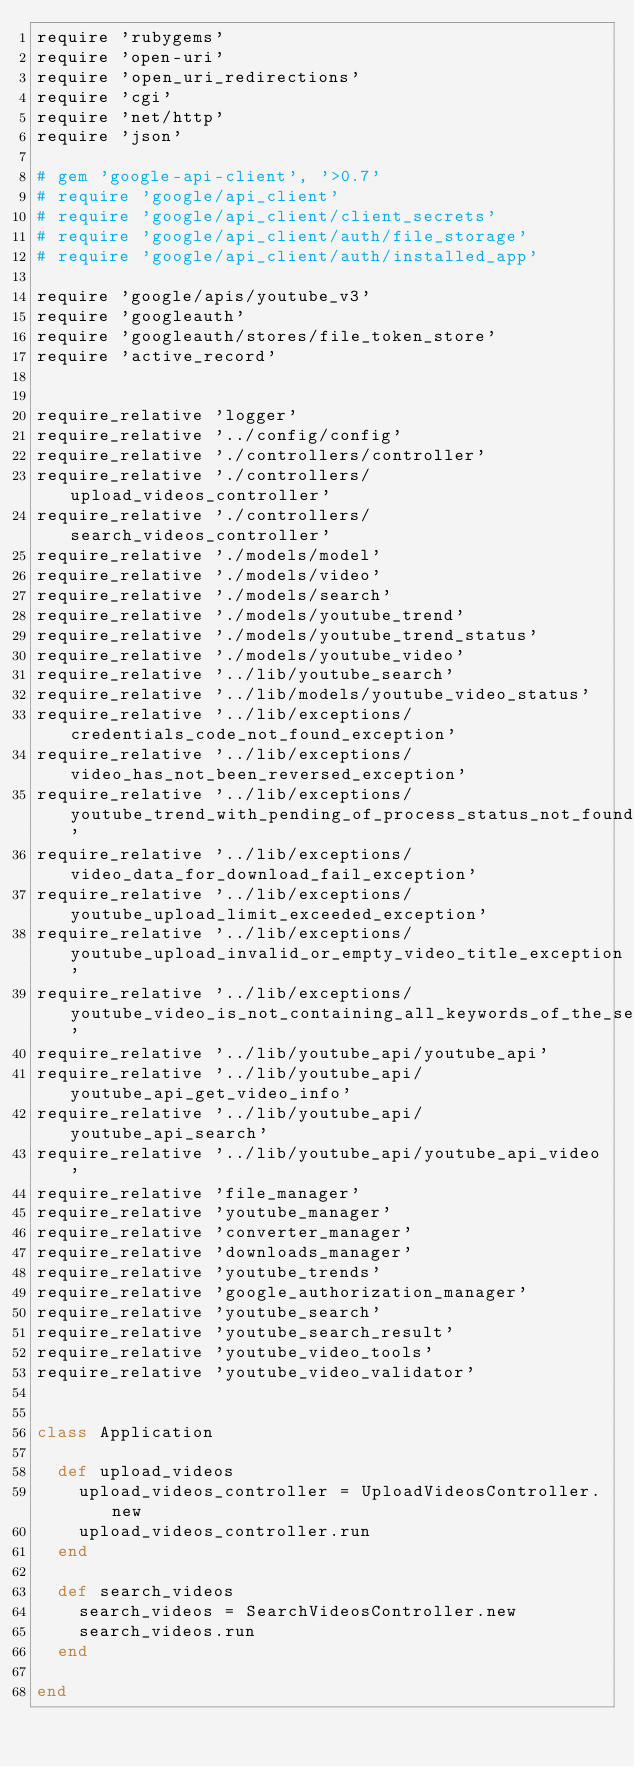Convert code to text. <code><loc_0><loc_0><loc_500><loc_500><_Ruby_>require 'rubygems'
require 'open-uri'
require 'open_uri_redirections'
require 'cgi'
require 'net/http'
require 'json'

# gem 'google-api-client', '>0.7'
# require 'google/api_client'
# require 'google/api_client/client_secrets'
# require 'google/api_client/auth/file_storage'
# require 'google/api_client/auth/installed_app'

require 'google/apis/youtube_v3'
require 'googleauth'
require 'googleauth/stores/file_token_store'
require 'active_record'


require_relative 'logger'
require_relative '../config/config'
require_relative './controllers/controller'
require_relative './controllers/upload_videos_controller'
require_relative './controllers/search_videos_controller'
require_relative './models/model'
require_relative './models/video'
require_relative './models/search'
require_relative './models/youtube_trend'
require_relative './models/youtube_trend_status'
require_relative './models/youtube_video'
require_relative '../lib/youtube_search'
require_relative '../lib/models/youtube_video_status'
require_relative '../lib/exceptions/credentials_code_not_found_exception'
require_relative '../lib/exceptions/video_has_not_been_reversed_exception'
require_relative '../lib/exceptions/youtube_trend_with_pending_of_process_status_not_found_exception'
require_relative '../lib/exceptions/video_data_for_download_fail_exception'
require_relative '../lib/exceptions/youtube_upload_limit_exceeded_exception'
require_relative '../lib/exceptions/youtube_upload_invalid_or_empty_video_title_exception'
require_relative '../lib/exceptions/youtube_video_is_not_containing_all_keywords_of_the_search_exception'
require_relative '../lib/youtube_api/youtube_api'
require_relative '../lib/youtube_api/youtube_api_get_video_info'
require_relative '../lib/youtube_api/youtube_api_search'
require_relative '../lib/youtube_api/youtube_api_video'
require_relative 'file_manager'
require_relative 'youtube_manager'
require_relative 'converter_manager'
require_relative 'downloads_manager'
require_relative 'youtube_trends'
require_relative 'google_authorization_manager'
require_relative 'youtube_search'
require_relative 'youtube_search_result'
require_relative 'youtube_video_tools'
require_relative 'youtube_video_validator'


class Application

  def upload_videos
    upload_videos_controller = UploadVideosController.new
    upload_videos_controller.run
  end

  def search_videos
    search_videos = SearchVideosController.new
    search_videos.run
  end

end


</code> 